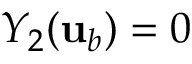Convert formula to latex. <formula><loc_0><loc_0><loc_500><loc_500>Y _ { 2 } ( { u } _ { b } ) = 0</formula> 